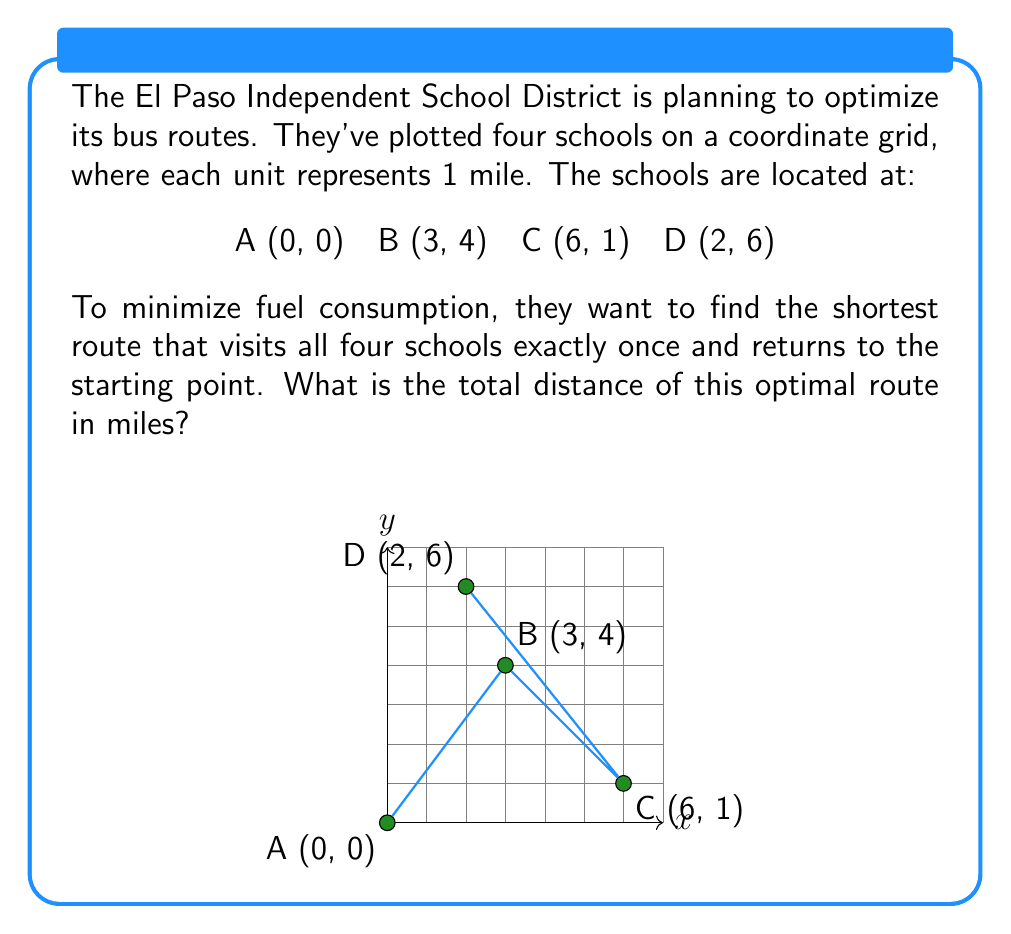Could you help me with this problem? To solve this problem, we need to:
1. Calculate the distances between all pairs of schools
2. Find the shortest route that visits all schools once and returns to the start

Step 1: Calculate distances using the distance formula
$$d = \sqrt{(x_2-x_1)^2 + (y_2-y_1)^2}$$

AB = $\sqrt{(3-0)^2 + (4-0)^2} = 5$
AC = $\sqrt{(6-0)^2 + (1-0)^2} = \sqrt{37}$
AD = $\sqrt{(2-0)^2 + (6-0)^2} = \sqrt{40}$
BC = $\sqrt{(6-3)^2 + (1-4)^2} = \sqrt{18}$
BD = $\sqrt{(2-3)^2 + (6-4)^2} = \sqrt{5}$
CD = $\sqrt{(2-6)^2 + (6-1)^2} = \sqrt{41}$

Step 2: Find the shortest route
There are 24 possible routes (4! = 24). We need to check each one. The shortest route is:

A → B → D → C → A

Total distance = AB + BD + DC + CA
               = 5 + $\sqrt{5}$ + $\sqrt{41}$ + $\sqrt{37}$
               ≈ 18.69 miles

This route minimizes fuel consumption by traveling the shortest total distance while visiting all schools once and returning to the starting point.
Answer: 18.69 miles 